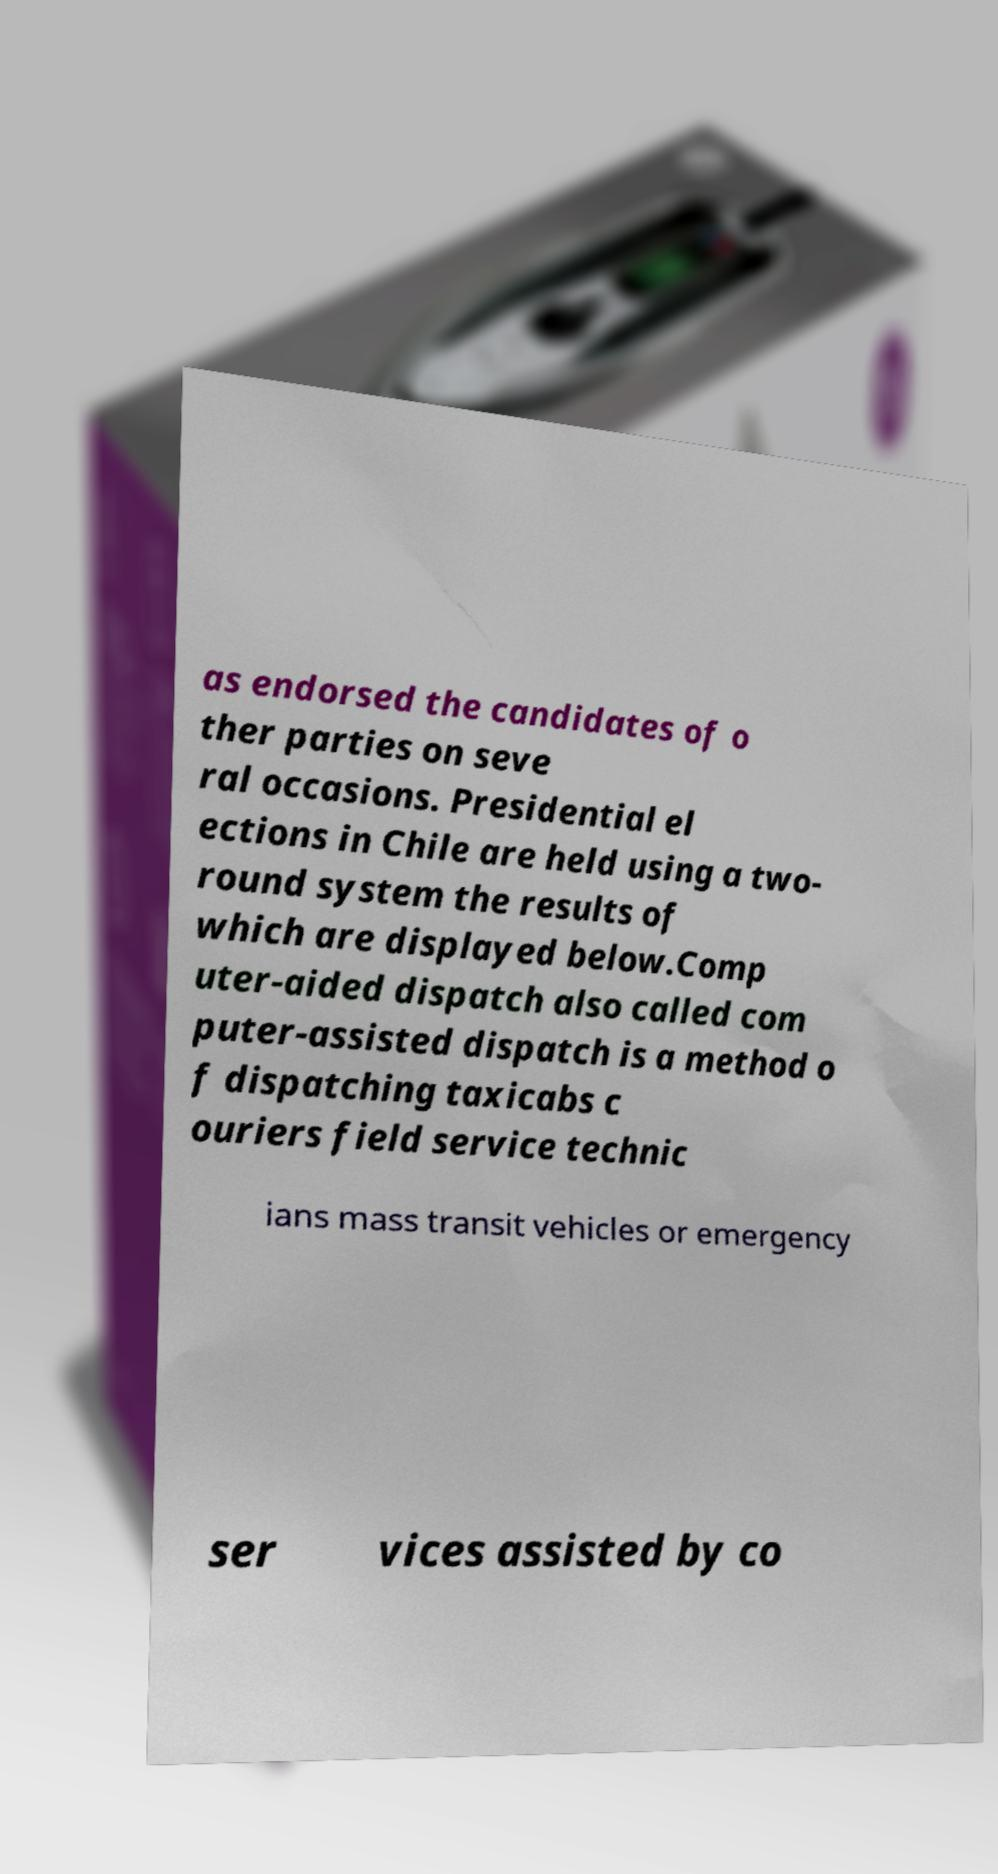Can you read and provide the text displayed in the image?This photo seems to have some interesting text. Can you extract and type it out for me? as endorsed the candidates of o ther parties on seve ral occasions. Presidential el ections in Chile are held using a two- round system the results of which are displayed below.Comp uter-aided dispatch also called com puter-assisted dispatch is a method o f dispatching taxicabs c ouriers field service technic ians mass transit vehicles or emergency ser vices assisted by co 